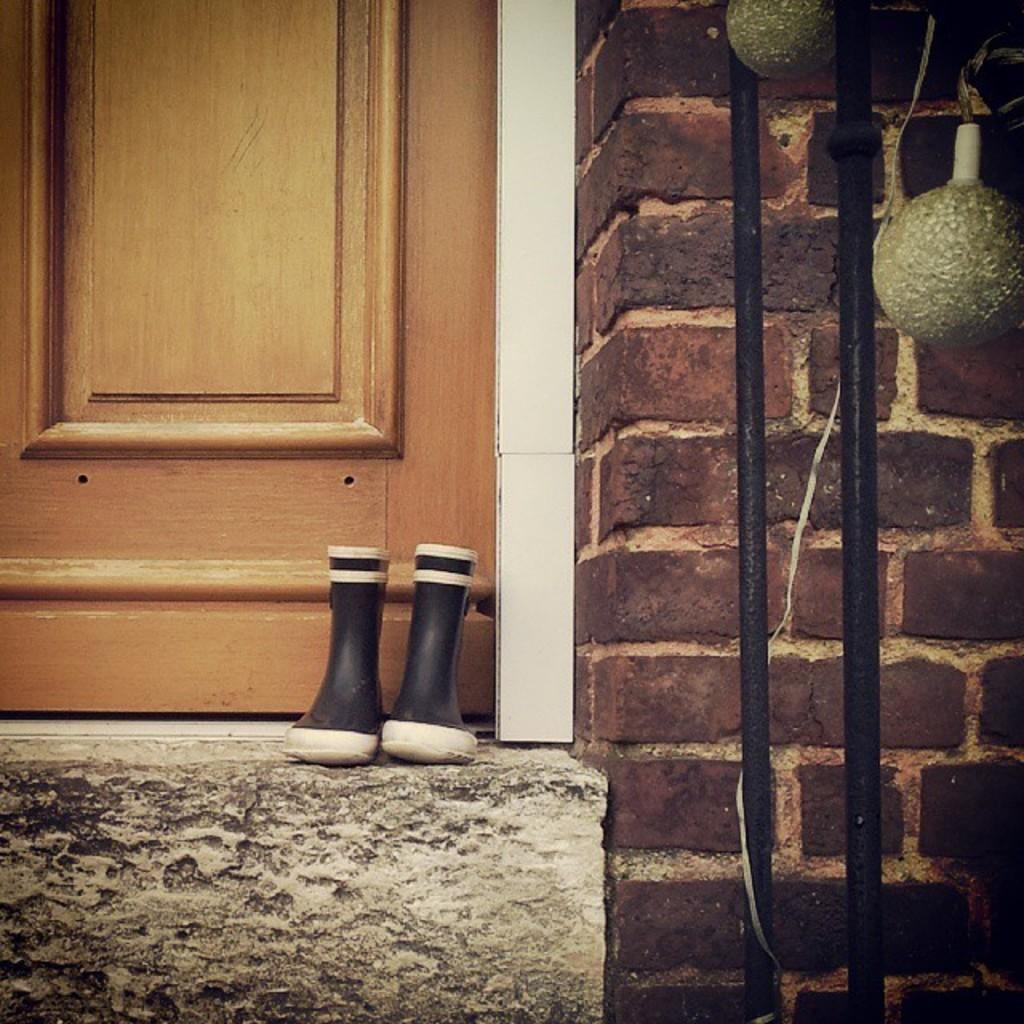What type of objects can be seen in the image? There are shoes, a wall, a door, and poles in the image. What color are the white color objects in the image? The white color objects in the image are not specified, but they are white. Can you describe the wall in the image? The wall is a part of the image, but its specific characteristics are not mentioned in the facts. What is the purpose of the birthday celebration in the image? There is no mention of a birthday celebration in the image, so it is not possible to determine its purpose. 